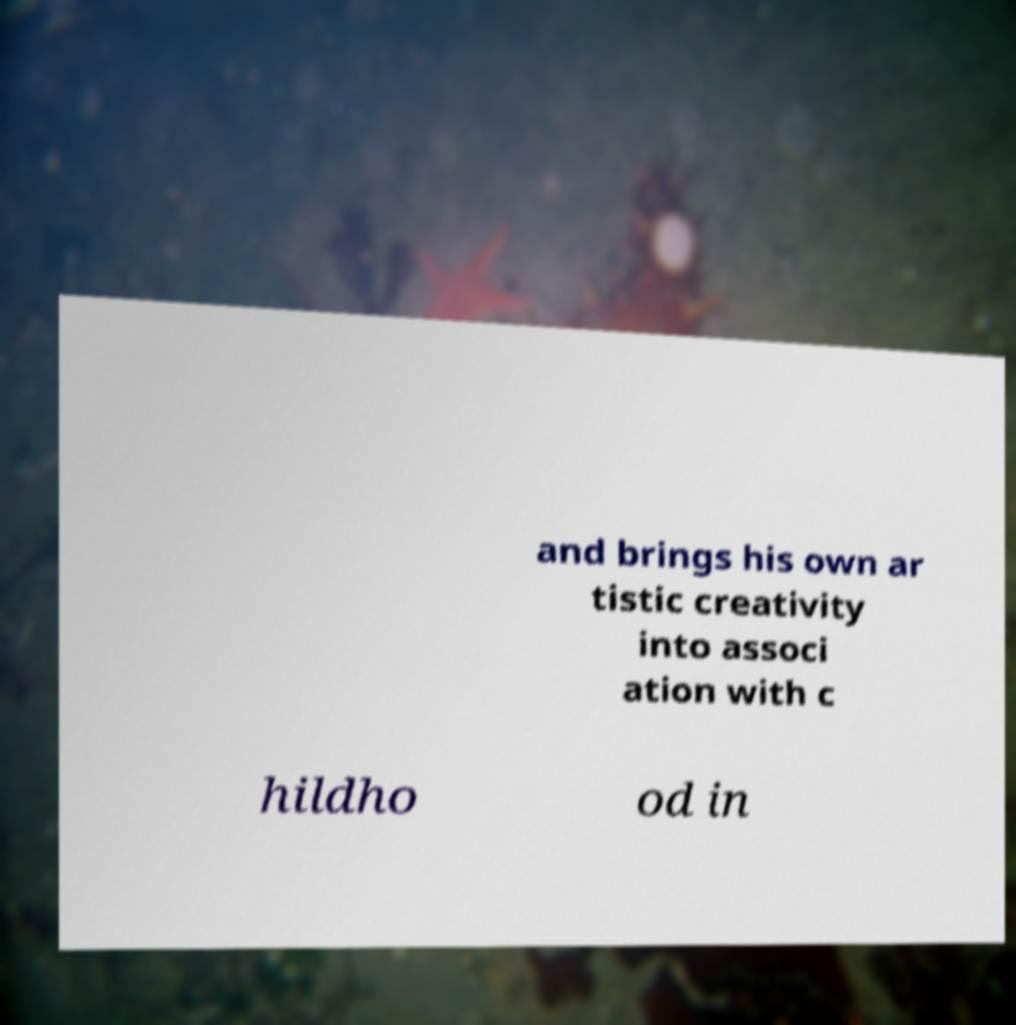Can you accurately transcribe the text from the provided image for me? and brings his own ar tistic creativity into associ ation with c hildho od in 